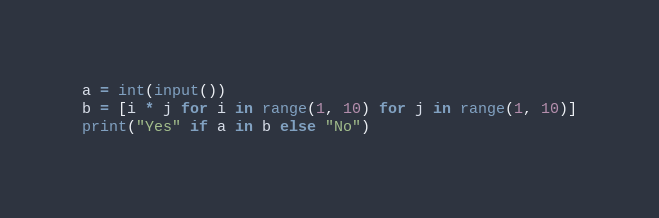<code> <loc_0><loc_0><loc_500><loc_500><_Python_>a = int(input())
b = [i * j for i in range(1, 10) for j in range(1, 10)]
print("Yes" if a in b else "No")
</code> 